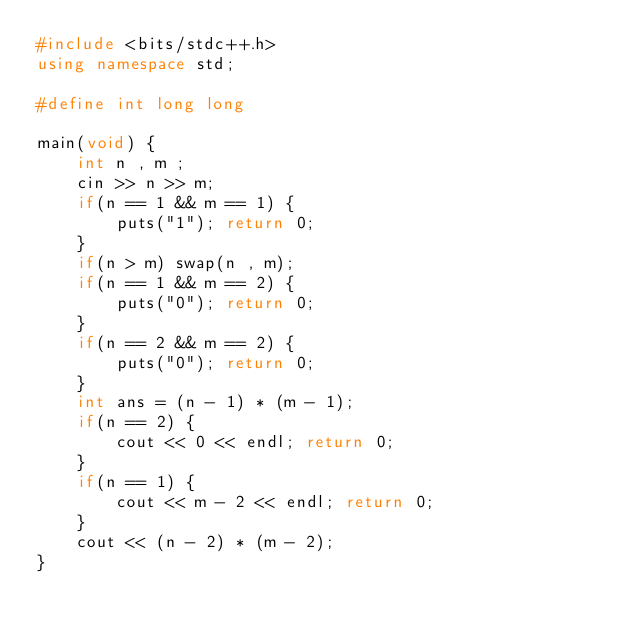Convert code to text. <code><loc_0><loc_0><loc_500><loc_500><_C++_>#include <bits/stdc++.h>
using namespace std;

#define int long long

main(void) {
	int n , m ;
	cin >> n >> m;
	if(n == 1 && m == 1) {
		puts("1"); return 0;
	}
	if(n > m) swap(n , m);
	if(n == 1 && m == 2) {
		puts("0"); return 0;
	}
	if(n == 2 && m == 2) {
		puts("0"); return 0; 
	}
	int ans = (n - 1) * (m - 1);
	if(n == 2) {
		cout << 0 << endl; return 0;
	}
	if(n == 1) {
		cout << m - 2 << endl; return 0;
	}
	cout << (n - 2) * (m - 2);
}</code> 